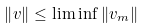<formula> <loc_0><loc_0><loc_500><loc_500>\left \| v \right \| \leq \lim \inf \left \| v _ { m } \right \|</formula> 